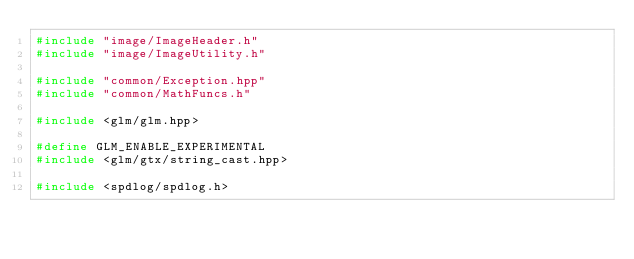Convert code to text. <code><loc_0><loc_0><loc_500><loc_500><_C++_>#include "image/ImageHeader.h"
#include "image/ImageUtility.h"

#include "common/Exception.hpp"
#include "common/MathFuncs.h"

#include <glm/glm.hpp>

#define GLM_ENABLE_EXPERIMENTAL
#include <glm/gtx/string_cast.hpp>

#include <spdlog/spdlog.h>

</code> 